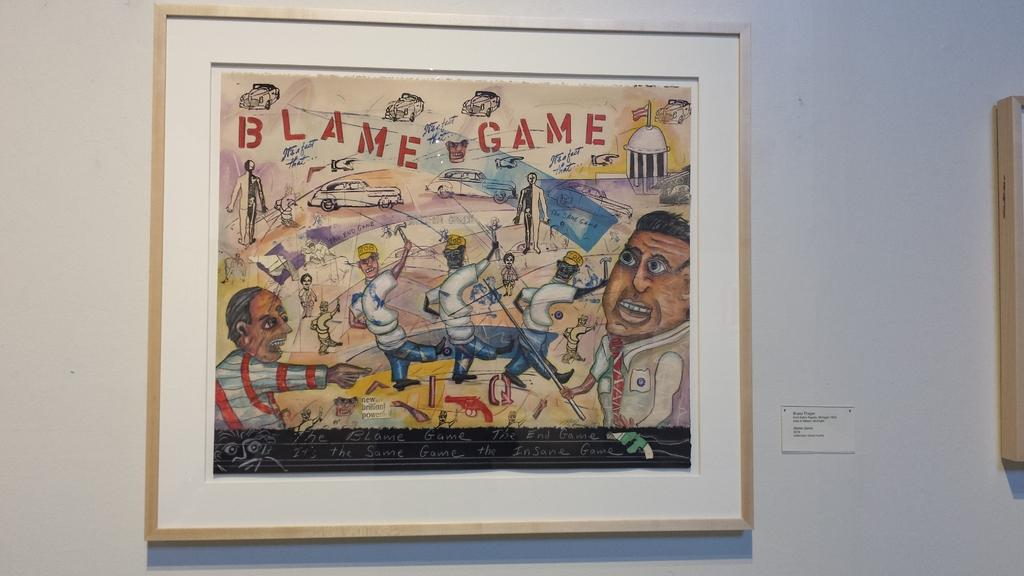<image>
Create a compact narrative representing the image presented. A framed poster with cartoon charicatures of people titled Blame Game. 